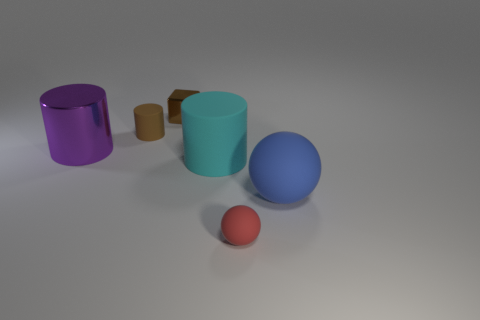What shape is the red matte thing?
Offer a terse response. Sphere. What number of things are tiny brown cylinders or tiny brown objects to the right of the small matte cylinder?
Offer a terse response. 2. Do the shiny object on the left side of the tiny metal block and the tiny matte cylinder have the same color?
Your answer should be very brief. No. There is a cylinder that is both on the right side of the big purple metal cylinder and on the left side of the small brown shiny thing; what is its color?
Provide a succinct answer. Brown. There is a big cyan cylinder to the right of the large purple metallic cylinder; what material is it?
Provide a short and direct response. Rubber. How big is the blue rubber ball?
Your answer should be compact. Large. What number of purple things are either matte cylinders or tiny things?
Offer a very short reply. 0. How big is the metallic object on the left side of the matte cylinder that is behind the purple cylinder?
Keep it short and to the point. Large. Is the color of the small metal object the same as the metallic thing that is in front of the brown block?
Offer a terse response. No. What number of other objects are the same material as the small red sphere?
Your response must be concise. 3. 